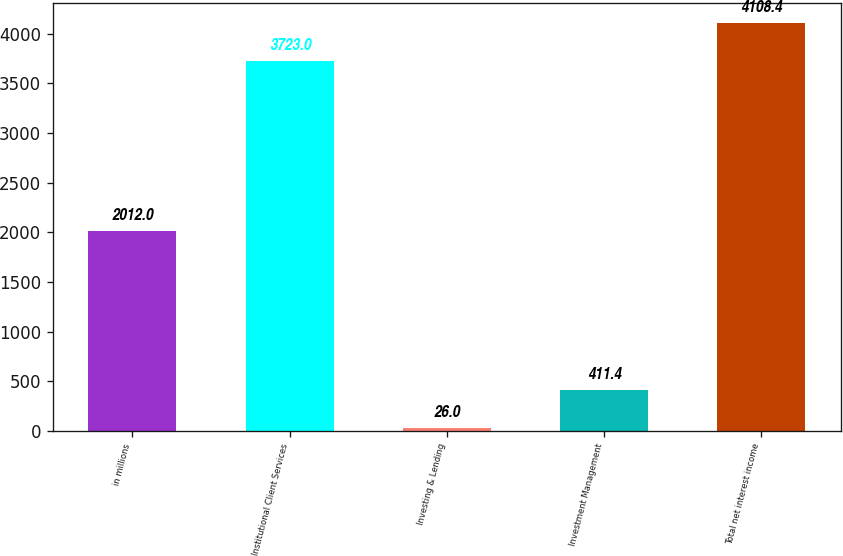Convert chart. <chart><loc_0><loc_0><loc_500><loc_500><bar_chart><fcel>in millions<fcel>Institutional Client Services<fcel>Investing & Lending<fcel>Investment Management<fcel>Total net interest income<nl><fcel>2012<fcel>3723<fcel>26<fcel>411.4<fcel>4108.4<nl></chart> 